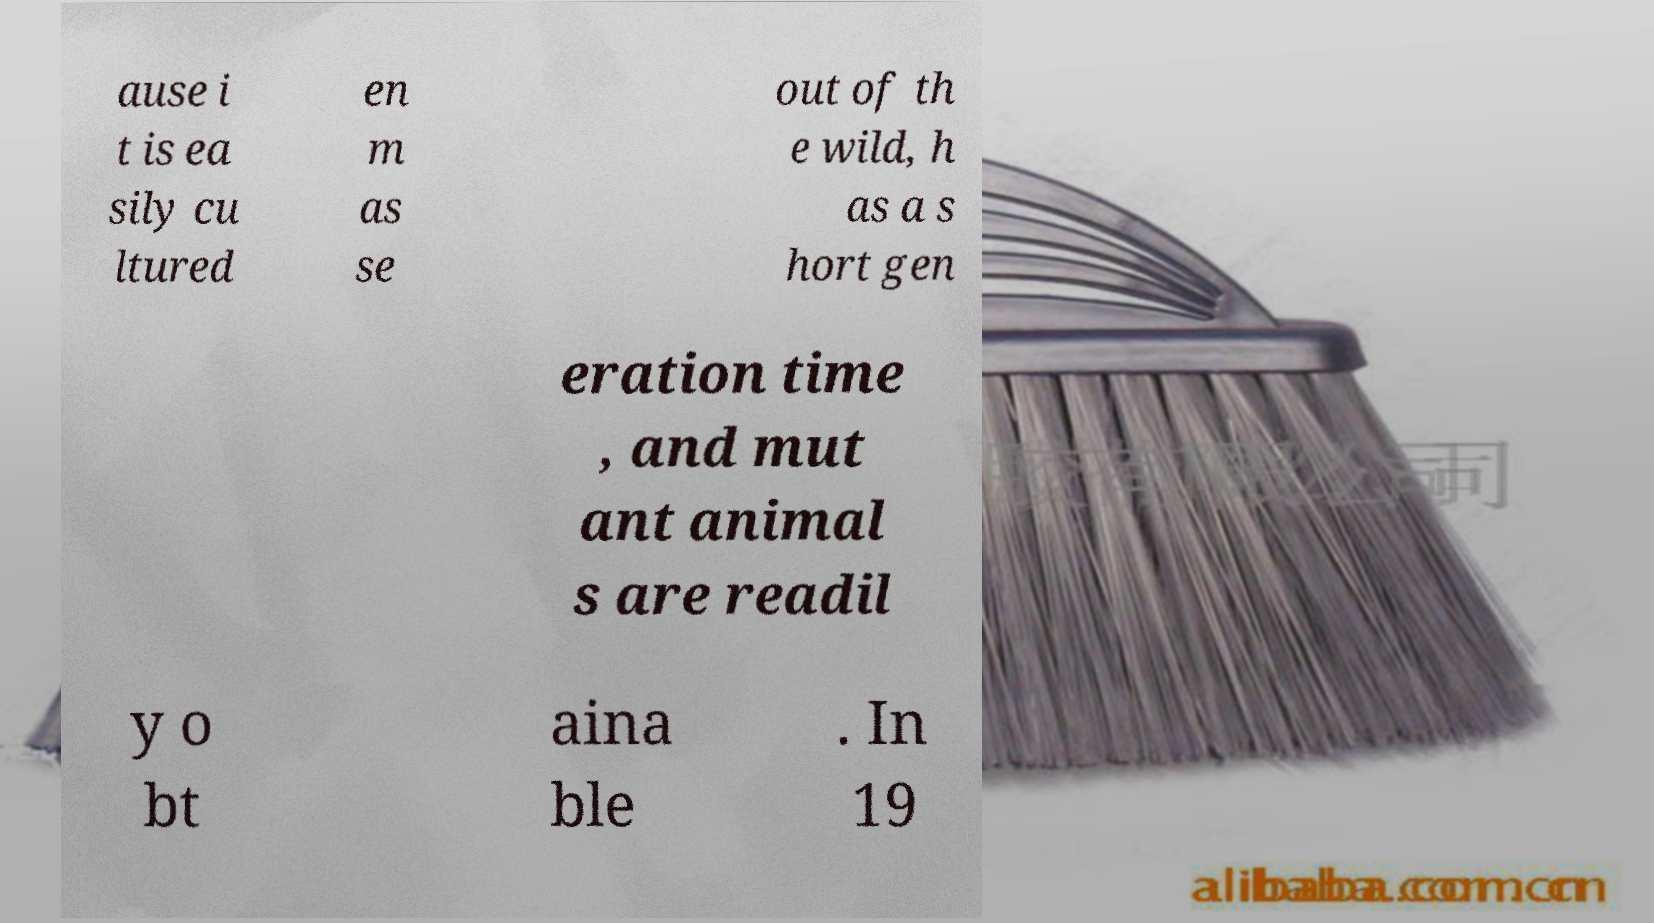Could you extract and type out the text from this image? ause i t is ea sily cu ltured en m as se out of th e wild, h as a s hort gen eration time , and mut ant animal s are readil y o bt aina ble . In 19 